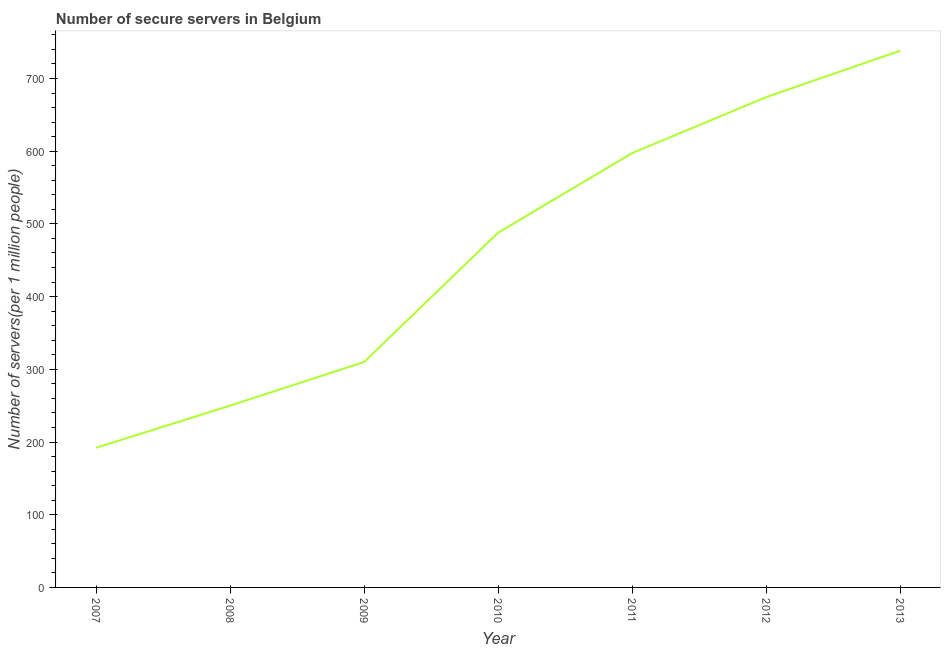What is the number of secure internet servers in 2011?
Provide a short and direct response. 597.41. Across all years, what is the maximum number of secure internet servers?
Provide a succinct answer. 738.28. Across all years, what is the minimum number of secure internet servers?
Ensure brevity in your answer.  192.08. In which year was the number of secure internet servers maximum?
Make the answer very short. 2013. What is the sum of the number of secure internet servers?
Provide a succinct answer. 3250.31. What is the difference between the number of secure internet servers in 2009 and 2012?
Make the answer very short. -364.31. What is the average number of secure internet servers per year?
Give a very brief answer. 464.33. What is the median number of secure internet servers?
Your response must be concise. 487.99. In how many years, is the number of secure internet servers greater than 440 ?
Ensure brevity in your answer.  4. What is the ratio of the number of secure internet servers in 2010 to that in 2011?
Offer a terse response. 0.82. What is the difference between the highest and the second highest number of secure internet servers?
Provide a succinct answer. 63.87. Is the sum of the number of secure internet servers in 2007 and 2012 greater than the maximum number of secure internet servers across all years?
Your answer should be very brief. Yes. What is the difference between the highest and the lowest number of secure internet servers?
Provide a succinct answer. 546.19. In how many years, is the number of secure internet servers greater than the average number of secure internet servers taken over all years?
Provide a short and direct response. 4. How many lines are there?
Your response must be concise. 1. How many years are there in the graph?
Your response must be concise. 7. What is the difference between two consecutive major ticks on the Y-axis?
Provide a succinct answer. 100. Does the graph contain any zero values?
Offer a very short reply. No. What is the title of the graph?
Your answer should be very brief. Number of secure servers in Belgium. What is the label or title of the X-axis?
Your answer should be very brief. Year. What is the label or title of the Y-axis?
Provide a succinct answer. Number of servers(per 1 million people). What is the Number of servers(per 1 million people) of 2007?
Give a very brief answer. 192.08. What is the Number of servers(per 1 million people) in 2008?
Make the answer very short. 250.05. What is the Number of servers(per 1 million people) of 2009?
Offer a terse response. 310.1. What is the Number of servers(per 1 million people) in 2010?
Make the answer very short. 487.99. What is the Number of servers(per 1 million people) in 2011?
Ensure brevity in your answer.  597.41. What is the Number of servers(per 1 million people) of 2012?
Provide a short and direct response. 674.41. What is the Number of servers(per 1 million people) in 2013?
Ensure brevity in your answer.  738.28. What is the difference between the Number of servers(per 1 million people) in 2007 and 2008?
Your response must be concise. -57.97. What is the difference between the Number of servers(per 1 million people) in 2007 and 2009?
Offer a very short reply. -118.02. What is the difference between the Number of servers(per 1 million people) in 2007 and 2010?
Offer a terse response. -295.91. What is the difference between the Number of servers(per 1 million people) in 2007 and 2011?
Your answer should be compact. -405.33. What is the difference between the Number of servers(per 1 million people) in 2007 and 2012?
Keep it short and to the point. -482.33. What is the difference between the Number of servers(per 1 million people) in 2007 and 2013?
Offer a very short reply. -546.19. What is the difference between the Number of servers(per 1 million people) in 2008 and 2009?
Give a very brief answer. -60.05. What is the difference between the Number of servers(per 1 million people) in 2008 and 2010?
Offer a very short reply. -237.94. What is the difference between the Number of servers(per 1 million people) in 2008 and 2011?
Keep it short and to the point. -347.36. What is the difference between the Number of servers(per 1 million people) in 2008 and 2012?
Your response must be concise. -424.36. What is the difference between the Number of servers(per 1 million people) in 2008 and 2013?
Offer a terse response. -488.23. What is the difference between the Number of servers(per 1 million people) in 2009 and 2010?
Provide a succinct answer. -177.89. What is the difference between the Number of servers(per 1 million people) in 2009 and 2011?
Make the answer very short. -287.31. What is the difference between the Number of servers(per 1 million people) in 2009 and 2012?
Offer a very short reply. -364.31. What is the difference between the Number of servers(per 1 million people) in 2009 and 2013?
Offer a terse response. -428.17. What is the difference between the Number of servers(per 1 million people) in 2010 and 2011?
Your answer should be compact. -109.42. What is the difference between the Number of servers(per 1 million people) in 2010 and 2012?
Make the answer very short. -186.42. What is the difference between the Number of servers(per 1 million people) in 2010 and 2013?
Provide a succinct answer. -250.28. What is the difference between the Number of servers(per 1 million people) in 2011 and 2012?
Your response must be concise. -77. What is the difference between the Number of servers(per 1 million people) in 2011 and 2013?
Your response must be concise. -140.87. What is the difference between the Number of servers(per 1 million people) in 2012 and 2013?
Your answer should be compact. -63.87. What is the ratio of the Number of servers(per 1 million people) in 2007 to that in 2008?
Provide a succinct answer. 0.77. What is the ratio of the Number of servers(per 1 million people) in 2007 to that in 2009?
Give a very brief answer. 0.62. What is the ratio of the Number of servers(per 1 million people) in 2007 to that in 2010?
Provide a short and direct response. 0.39. What is the ratio of the Number of servers(per 1 million people) in 2007 to that in 2011?
Make the answer very short. 0.32. What is the ratio of the Number of servers(per 1 million people) in 2007 to that in 2012?
Give a very brief answer. 0.28. What is the ratio of the Number of servers(per 1 million people) in 2007 to that in 2013?
Your response must be concise. 0.26. What is the ratio of the Number of servers(per 1 million people) in 2008 to that in 2009?
Your response must be concise. 0.81. What is the ratio of the Number of servers(per 1 million people) in 2008 to that in 2010?
Your answer should be compact. 0.51. What is the ratio of the Number of servers(per 1 million people) in 2008 to that in 2011?
Your response must be concise. 0.42. What is the ratio of the Number of servers(per 1 million people) in 2008 to that in 2012?
Give a very brief answer. 0.37. What is the ratio of the Number of servers(per 1 million people) in 2008 to that in 2013?
Make the answer very short. 0.34. What is the ratio of the Number of servers(per 1 million people) in 2009 to that in 2010?
Offer a very short reply. 0.64. What is the ratio of the Number of servers(per 1 million people) in 2009 to that in 2011?
Offer a very short reply. 0.52. What is the ratio of the Number of servers(per 1 million people) in 2009 to that in 2012?
Offer a very short reply. 0.46. What is the ratio of the Number of servers(per 1 million people) in 2009 to that in 2013?
Offer a terse response. 0.42. What is the ratio of the Number of servers(per 1 million people) in 2010 to that in 2011?
Your answer should be compact. 0.82. What is the ratio of the Number of servers(per 1 million people) in 2010 to that in 2012?
Ensure brevity in your answer.  0.72. What is the ratio of the Number of servers(per 1 million people) in 2010 to that in 2013?
Offer a terse response. 0.66. What is the ratio of the Number of servers(per 1 million people) in 2011 to that in 2012?
Offer a very short reply. 0.89. What is the ratio of the Number of servers(per 1 million people) in 2011 to that in 2013?
Give a very brief answer. 0.81. What is the ratio of the Number of servers(per 1 million people) in 2012 to that in 2013?
Provide a succinct answer. 0.91. 